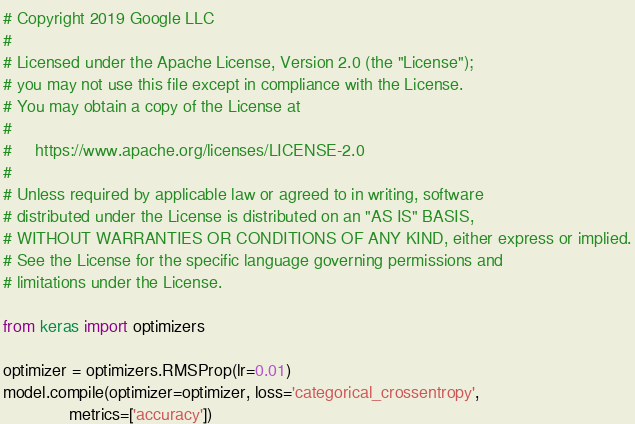<code> <loc_0><loc_0><loc_500><loc_500><_Python_># Copyright 2019 Google LLC
#
# Licensed under the Apache License, Version 2.0 (the "License");
# you may not use this file except in compliance with the License.
# You may obtain a copy of the License at
#
#     https://www.apache.org/licenses/LICENSE-2.0
#
# Unless required by applicable law or agreed to in writing, software
# distributed under the License is distributed on an "AS IS" BASIS,
# WITHOUT WARRANTIES OR CONDITIONS OF ANY KIND, either express or implied.
# See the License for the specific language governing permissions and
# limitations under the License.

from keras import optimizers

optimizer = optimizers.RMSProp(lr=0.01)
model.compile(optimizer=optimizer, loss='categorical_crossentropy', 
              metrics=['accuracy'])</code> 